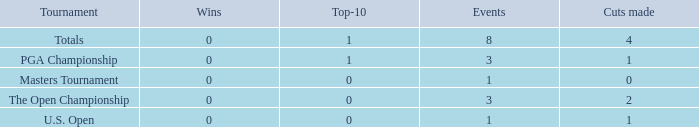For majors with 8 events played and more than 1 made cut, what is the most top-10s recorded? 1.0. 